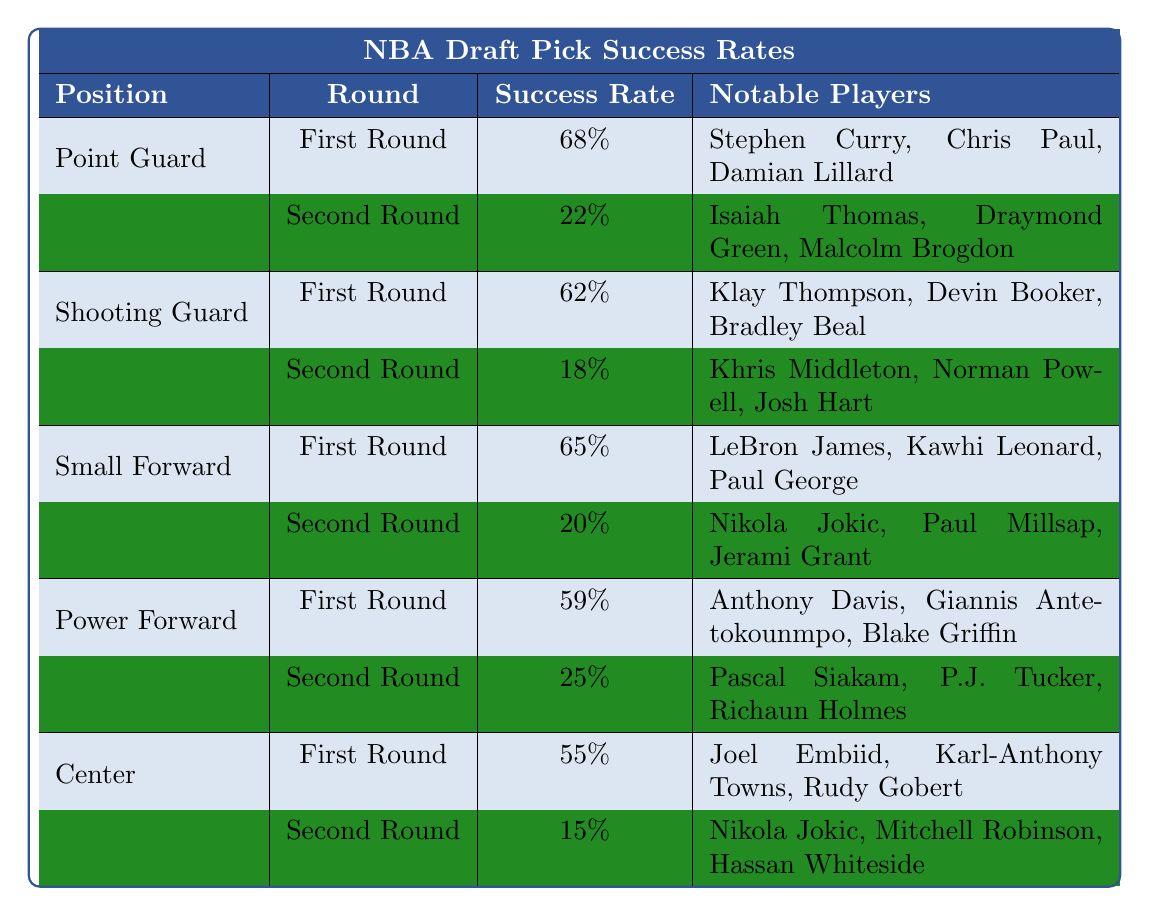What is the success rate for Point Guards in the First Round? The table shows that the success rate for Point Guards in the First Round is 68%.
Answer: 68% Which position has the highest success rate in the First Round? The highest success rate in the First Round is 68% for Point Guards.
Answer: Point Guard What is the difference in success rate between Shooting Guards and Power Forwards in the First Round? The success rate for Shooting Guards in the First Round is 62% and for Power Forwards is 59%. The difference is 62% - 59% = 3%.
Answer: 3% How many notable players are listed for the Small Forward position? The table lists three notable players for the Small Forward position: LeBron James, Kawhi Leonard, and Paul George.
Answer: 3 Is the success rate for centers in the Second Round higher than for Shooting Guards? The success rate for centers in the Second Round is 15%, whereas for Shooting Guards, it is 18%. Since 15% is less than 18%, the statement is false.
Answer: No What is the average success rate for First Round picks across all positions? The success rates for First Round picks are 68%, 62%, 65%, 59%, and 55%. Summing these gives 68 + 62 + 65 + 59 + 55 = 309. There are 5 positions, so the average is 309 / 5 = 61.8%.
Answer: 61.8% Which notable player appears for both the Second Round of Centers and as a notable player in the table? Nikola Jokic is noted under both the Second Round of Centers and under the list of notable players in the Small Forward category.
Answer: Yes What position has the least successful Second Round success rate? The Second Round success rates for all positions are 22% for Point Guards, 18% for Shooting Guards, 20% for Small Forwards, 25% for Power Forwards, and 15% for Centers. The least successful rate is 15% for Centers.
Answer: Center What is the total success rate from both rounds for the Power Forward position? For Power Forwards, the First Round success rate is 59% and the Second Round is 25%. Adding these gives 59 + 25 = 84%.
Answer: 84% Which position has the notable player with the lowest success rate in the Second Round? The success rate for Centers in the Second Round is 15%, which is the lowest among all listed positions.
Answer: Center 